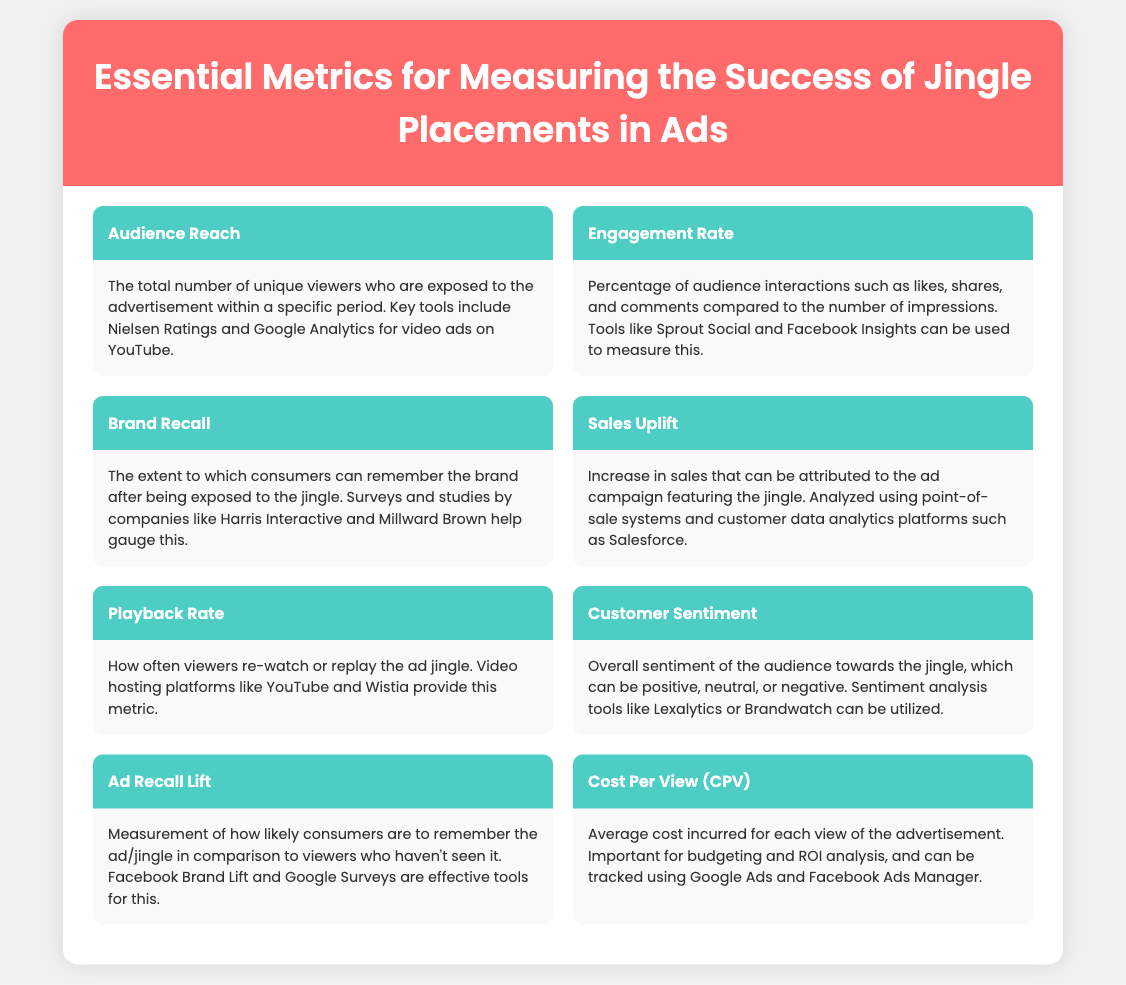what is the first essential metric listed? The first metric mentioned in the document is Audience Reach, which is displayed at the top of the list.
Answer: Audience Reach how is engagement rate defined? The document explains the engagement rate as a percentage of audience interactions such as likes, shares, and comments compared to impressions.
Answer: Percentage of audience interactions which tool is mentioned for measuring brand recall? The document cites Harris Interactive as a company that conducts surveys to gauge brand recall.
Answer: Harris Interactive what is the primary focus of the sales uplift metric? The sales uplift metric primarily focuses on the increase in sales attributed to the ad campaign featuring the jingle.
Answer: Increase in sales which sentiment analysis tools are listed? The document mentions Lexalytics and Brandwatch as tools for conducting sentiment analysis.
Answer: Lexalytics and Brandwatch how is playback rate measured? Playback rate is measured by how often viewers re-watch or replay the ad jingle, according to the video hosting platforms mentioned.
Answer: Video hosting platforms what does CPV stand for? The document defines CPV as Cost Per View, which is the average cost incurred for each view of the advertisement.
Answer: Cost Per View which two platforms can track cost per view? Google Ads and Facebook Ads Manager are the two platforms mentioned for tracking cost per view.
Answer: Google Ads and Facebook Ads Manager what is the significance of ad recall lift? Ad recall lift measures how likely consumers are to remember the ad/jingle compared to those who haven't seen it.
Answer: Likelihood of remembering the ad/jingle 